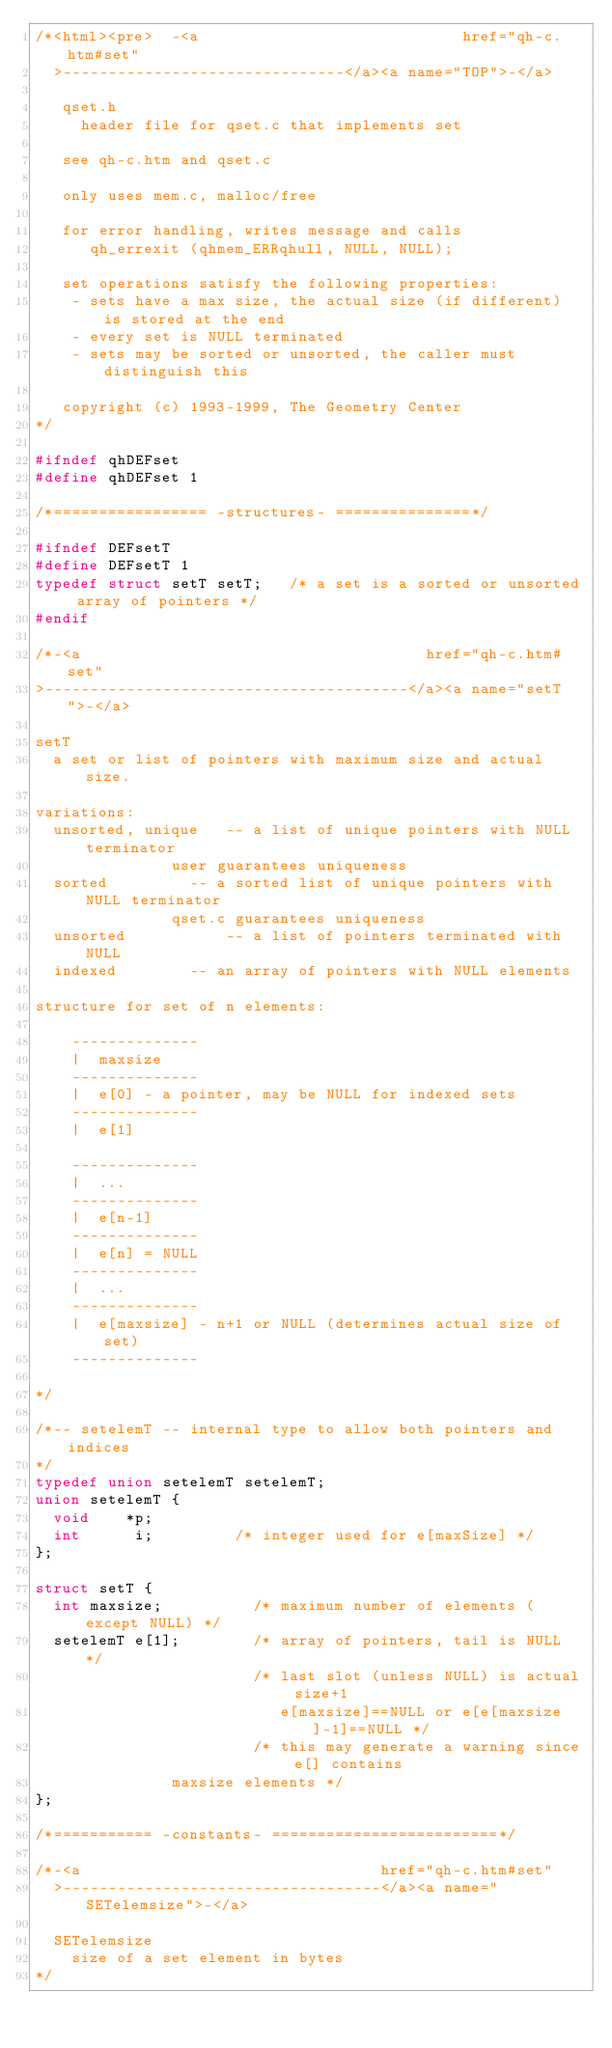<code> <loc_0><loc_0><loc_500><loc_500><_C++_>/*<html><pre>  -<a                             href="qh-c.htm#set"
  >-------------------------------</a><a name="TOP">-</a>

   qset.h
     header file for qset.c that implements set

   see qh-c.htm and qset.c
   
   only uses mem.c, malloc/free

   for error handling, writes message and calls
      qh_errexit (qhmem_ERRqhull, NULL, NULL);
   
   set operations satisfy the following properties:
    - sets have a max size, the actual size (if different) is stored at the end
    - every set is NULL terminated
    - sets may be sorted or unsorted, the caller must distinguish this
   
   copyright (c) 1993-1999, The Geometry Center
*/

#ifndef qhDEFset
#define qhDEFset 1

/*================= -structures- ===============*/

#ifndef DEFsetT
#define DEFsetT 1
typedef struct setT setT;   /* a set is a sorted or unsorted array of pointers */
#endif

/*-<a                                      href="qh-c.htm#set"
>----------------------------------------</a><a name="setT">-</a>
   
setT
  a set or list of pointers with maximum size and actual size.

variations:
  unsorted, unique   -- a list of unique pointers with NULL terminator
  			   user guarantees uniqueness
  sorted	     -- a sorted list of unique pointers with NULL terminator
  			   qset.c guarantees uniqueness
  unsorted           -- a list of pointers terminated with NULL
  indexed  	     -- an array of pointers with NULL elements 

structure for set of n elements:

	--------------
	|  maxsize 
	--------------
	|  e[0] - a pointer, may be NULL for indexed sets
	--------------
	|  e[1]
	
	--------------
	|  ...
	--------------
	|  e[n-1]
	--------------
	|  e[n] = NULL
	--------------
	|  ...
	--------------
	|  e[maxsize] - n+1 or NULL (determines actual size of set)
	--------------

*/

/*-- setelemT -- internal type to allow both pointers and indices
*/
typedef union setelemT setelemT;
union setelemT {
  void    *p;
  int      i;         /* integer used for e[maxSize] */
};

struct setT {
  int maxsize;          /* maximum number of elements (except NULL) */
  setelemT e[1];        /* array of pointers, tail is NULL */
                        /* last slot (unless NULL) is actual size+1 
                           e[maxsize]==NULL or e[e[maxsize]-1]==NULL */
                        /* this may generate a warning since e[] contains
			   maxsize elements */
};

/*=========== -constants- =========================*/

/*-<a                                 href="qh-c.htm#set"
  >-----------------------------------</a><a name="SETelemsize">-</a>
   
  SETelemsize
    size of a set element in bytes
*/</code> 